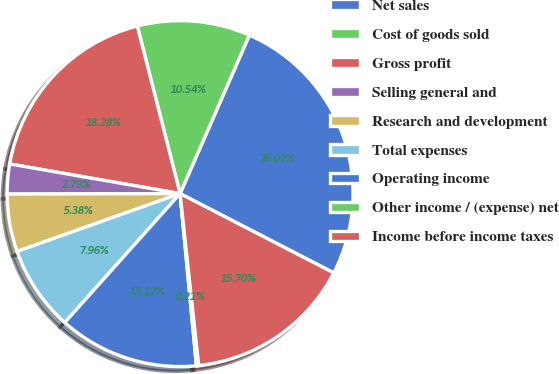Convert chart to OTSL. <chart><loc_0><loc_0><loc_500><loc_500><pie_chart><fcel>Net sales<fcel>Cost of goods sold<fcel>Gross profit<fcel>Selling general and<fcel>Research and development<fcel>Total expenses<fcel>Operating income<fcel>Other income / (expense) net<fcel>Income before income taxes<nl><fcel>26.02%<fcel>10.54%<fcel>18.28%<fcel>2.79%<fcel>5.38%<fcel>7.96%<fcel>13.12%<fcel>0.21%<fcel>15.7%<nl></chart> 